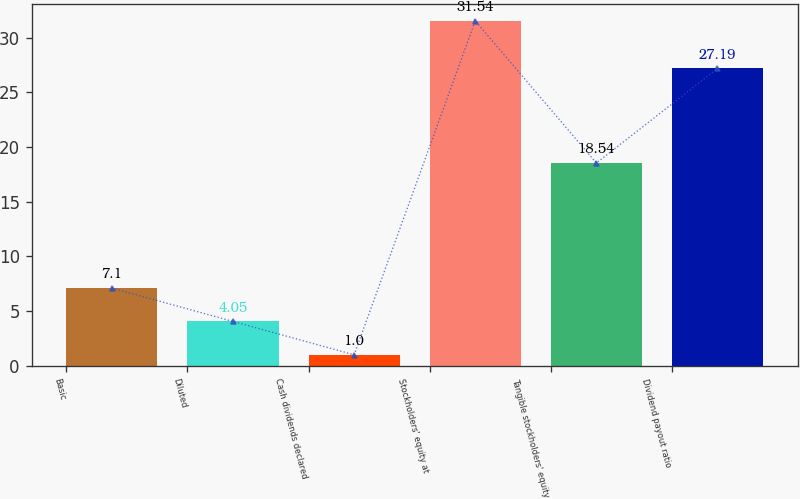Convert chart. <chart><loc_0><loc_0><loc_500><loc_500><bar_chart><fcel>Basic<fcel>Diluted<fcel>Cash dividends declared<fcel>Stockholders' equity at<fcel>Tangible stockholders' equity<fcel>Dividend payout ratio<nl><fcel>7.1<fcel>4.05<fcel>1<fcel>31.54<fcel>18.54<fcel>27.19<nl></chart> 